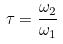Convert formula to latex. <formula><loc_0><loc_0><loc_500><loc_500>\tau = \frac { \omega _ { 2 } } { \omega _ { 1 } }</formula> 